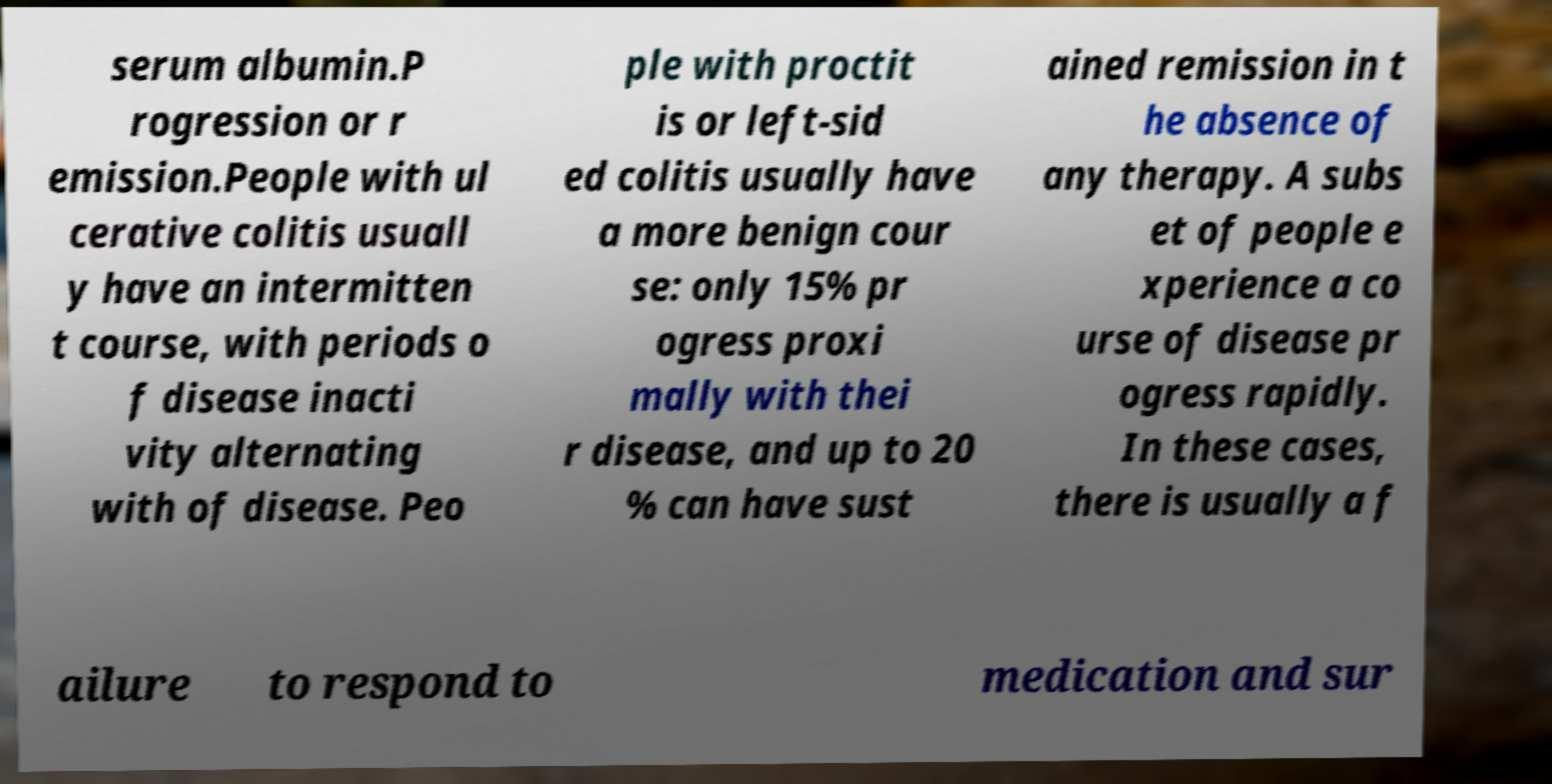Could you assist in decoding the text presented in this image and type it out clearly? serum albumin.P rogression or r emission.People with ul cerative colitis usuall y have an intermitten t course, with periods o f disease inacti vity alternating with of disease. Peo ple with proctit is or left-sid ed colitis usually have a more benign cour se: only 15% pr ogress proxi mally with thei r disease, and up to 20 % can have sust ained remission in t he absence of any therapy. A subs et of people e xperience a co urse of disease pr ogress rapidly. In these cases, there is usually a f ailure to respond to medication and sur 